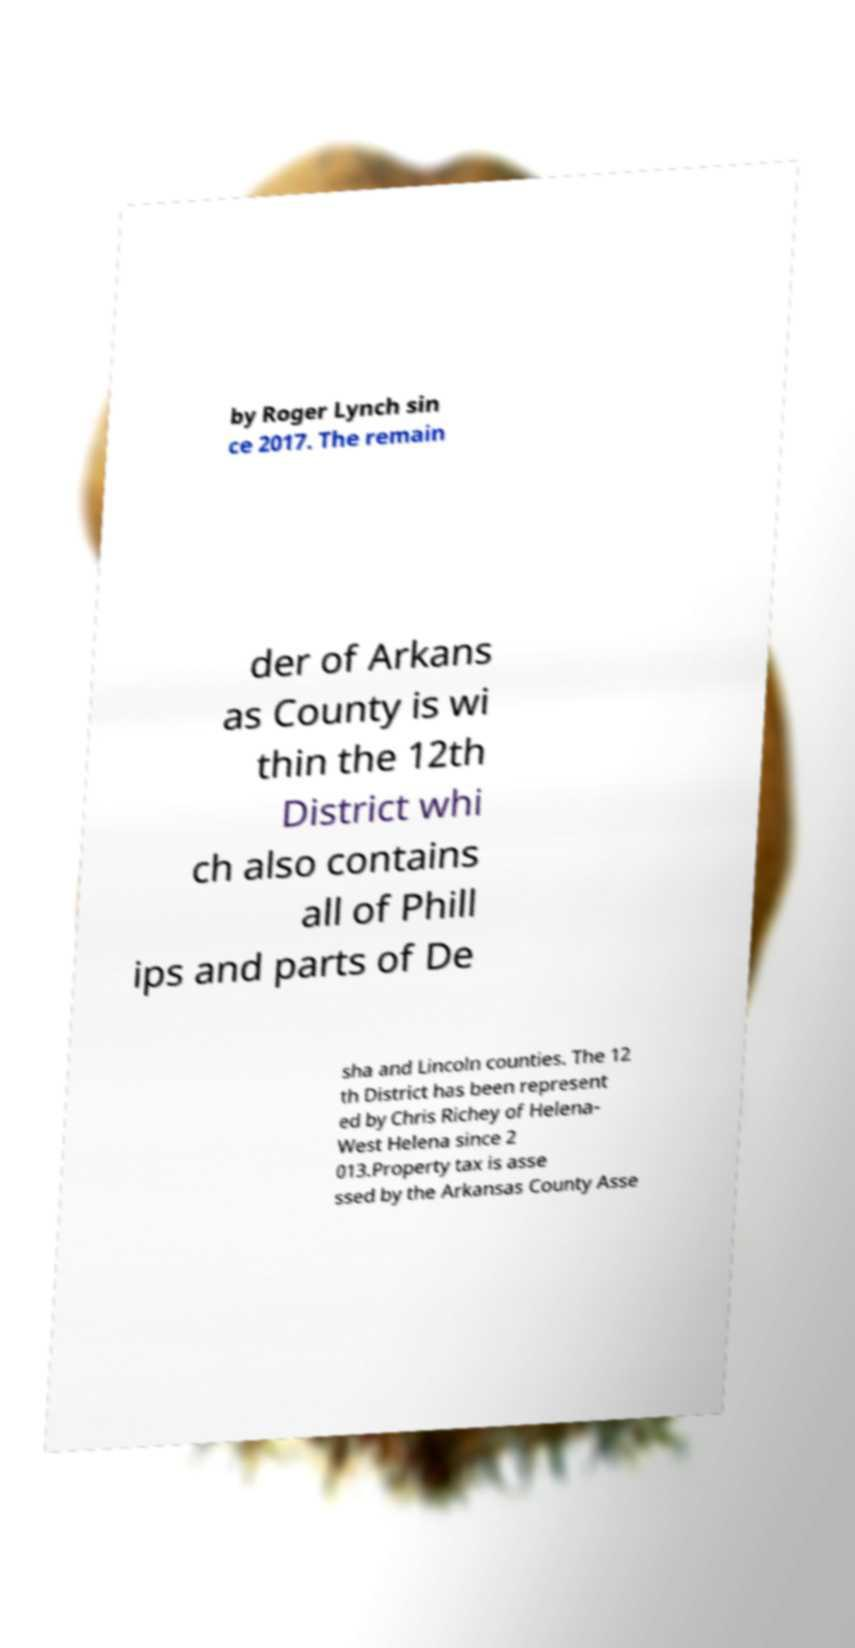Please read and relay the text visible in this image. What does it say? by Roger Lynch sin ce 2017. The remain der of Arkans as County is wi thin the 12th District whi ch also contains all of Phill ips and parts of De sha and Lincoln counties. The 12 th District has been represent ed by Chris Richey of Helena- West Helena since 2 013.Property tax is asse ssed by the Arkansas County Asse 